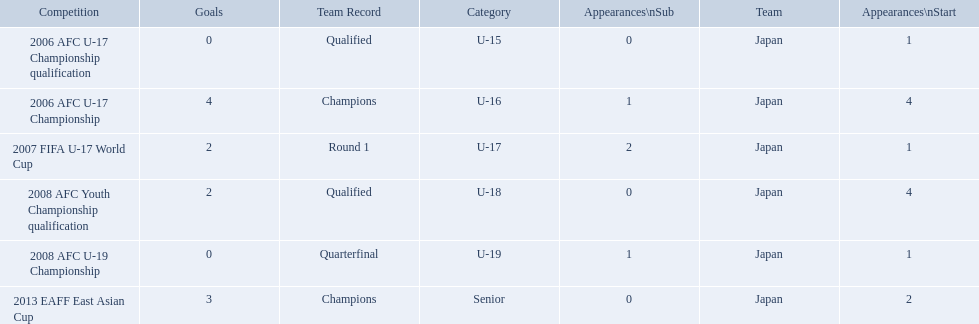What are all of the competitions? 2006 AFC U-17 Championship qualification, 2006 AFC U-17 Championship, 2007 FIFA U-17 World Cup, 2008 AFC Youth Championship qualification, 2008 AFC U-19 Championship, 2013 EAFF East Asian Cup. How many starting appearances were there? 1, 4, 1, 4, 1, 2. Help me parse the entirety of this table. {'header': ['Competition', 'Goals', 'Team Record', 'Category', 'Appearances\\nSub', 'Team', 'Appearances\\nStart'], 'rows': [['2006 AFC U-17 Championship qualification', '0', 'Qualified', 'U-15', '0', 'Japan', '1'], ['2006 AFC U-17 Championship', '4', 'Champions', 'U-16', '1', 'Japan', '4'], ['2007 FIFA U-17 World Cup', '2', 'Round 1', 'U-17', '2', 'Japan', '1'], ['2008 AFC Youth Championship qualification', '2', 'Qualified', 'U-18', '0', 'Japan', '4'], ['2008 AFC U-19 Championship', '0', 'Quarterfinal', 'U-19', '1', 'Japan', '1'], ['2013 EAFF East Asian Cup', '3', 'Champions', 'Senior', '0', 'Japan', '2']]} What about just during 2013 eaff east asian cup and 2007 fifa u-17 world cup? 1, 2. Which of those had more starting appearances? 2013 EAFF East Asian Cup. Which competitions had champions team records? 2006 AFC U-17 Championship, 2013 EAFF East Asian Cup. Of these competitions, which one was in the senior category? 2013 EAFF East Asian Cup. 